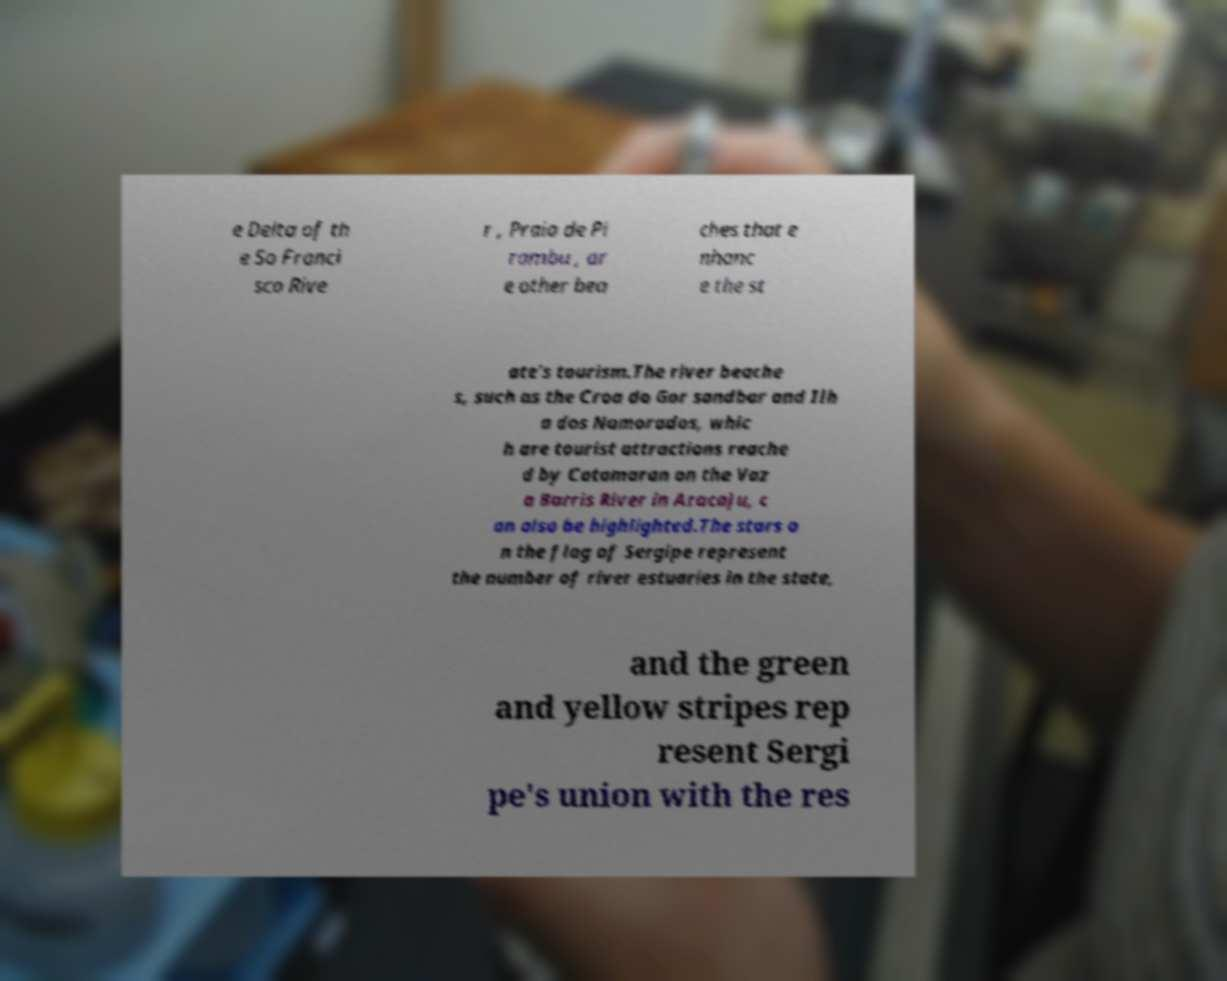Please identify and transcribe the text found in this image. e Delta of th e So Franci sco Rive r , Praia de Pi rambu , ar e other bea ches that e nhanc e the st ate's tourism.The river beache s, such as the Croa do Gor sandbar and Ilh a dos Namorados, whic h are tourist attractions reache d by Catamaran on the Vaz a Barris River in Aracaju, c an also be highlighted.The stars o n the flag of Sergipe represent the number of river estuaries in the state, and the green and yellow stripes rep resent Sergi pe's union with the res 